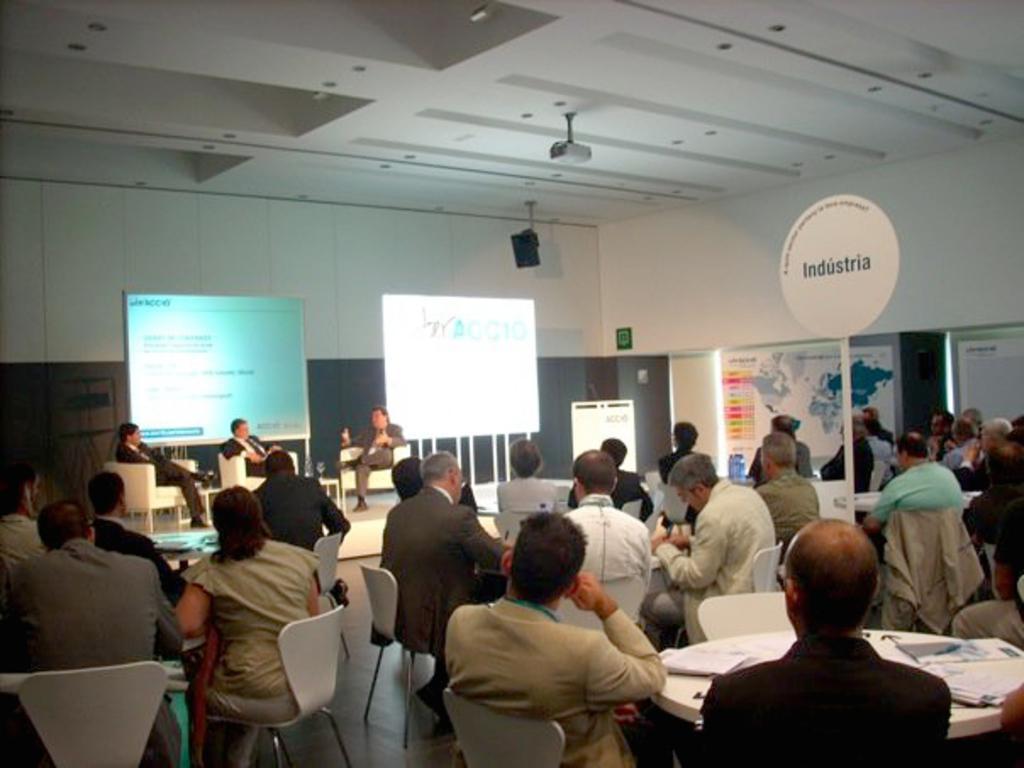Can you describe this image briefly? In this image three persons sitting on chairs on stage. There are group of people sitting on chair and seeing at these three persons on stage. There are two banners behind them. There is a projector attached to the roof of room. Right side there is a map poster. Beside there is a door. Right bottom there is a table on which books and papers are kept. 